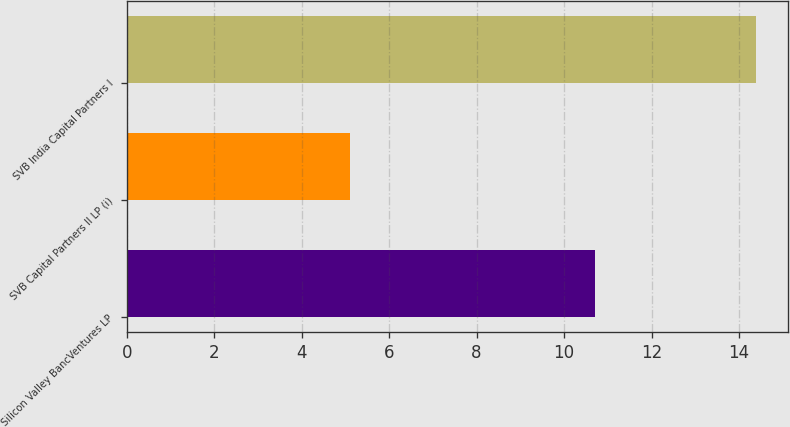Convert chart to OTSL. <chart><loc_0><loc_0><loc_500><loc_500><bar_chart><fcel>Silicon Valley BancVentures LP<fcel>SVB Capital Partners II LP (i)<fcel>SVB India Capital Partners I<nl><fcel>10.7<fcel>5.1<fcel>14.4<nl></chart> 